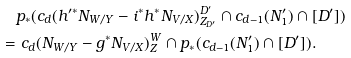Convert formula to latex. <formula><loc_0><loc_0><loc_500><loc_500>& p _ { * } ( c _ { d } ( h ^ { \prime * } N _ { W / Y } - i ^ { * } h ^ { * } N _ { V / X } ) ^ { D ^ { \prime } } _ { Z _ { D ^ { \prime } } } \cap c _ { d - 1 } ( N ^ { \prime } _ { 1 } ) \cap [ D ^ { \prime } ] ) \\ = & \ c _ { d } ( N _ { W / Y } - g ^ { * } N _ { V / X } ) ^ { W } _ { Z } \cap p _ { * } ( c _ { d - 1 } ( N ^ { \prime } _ { 1 } ) \cap [ D ^ { \prime } ] ) .</formula> 